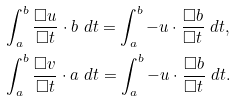Convert formula to latex. <formula><loc_0><loc_0><loc_500><loc_500>& \int _ { a } ^ { b } \frac { \Box u } { \Box t } \cdot b \ d t = \int _ { a } ^ { b } - u \cdot \frac { \Box b } { \Box t } \ d t , \\ & \int _ { a } ^ { b } \frac { \Box v } { \Box t } \cdot a \ d t = \int _ { a } ^ { b } - u \cdot \frac { \Box b } { \Box t } \ d t .</formula> 